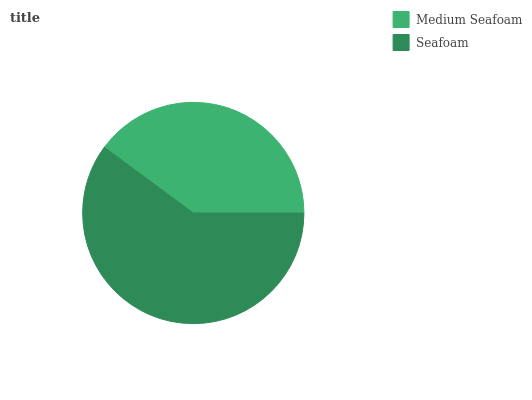Is Medium Seafoam the minimum?
Answer yes or no. Yes. Is Seafoam the maximum?
Answer yes or no. Yes. Is Seafoam the minimum?
Answer yes or no. No. Is Seafoam greater than Medium Seafoam?
Answer yes or no. Yes. Is Medium Seafoam less than Seafoam?
Answer yes or no. Yes. Is Medium Seafoam greater than Seafoam?
Answer yes or no. No. Is Seafoam less than Medium Seafoam?
Answer yes or no. No. Is Seafoam the high median?
Answer yes or no. Yes. Is Medium Seafoam the low median?
Answer yes or no. Yes. Is Medium Seafoam the high median?
Answer yes or no. No. Is Seafoam the low median?
Answer yes or no. No. 